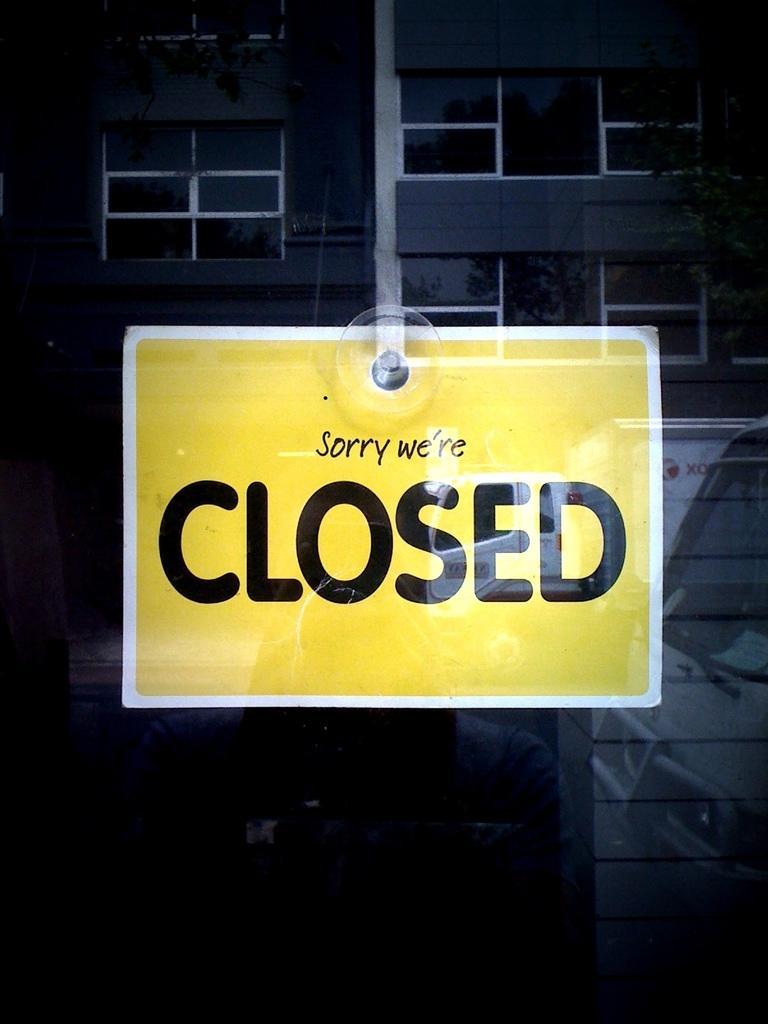Please provide a concise description of this image. In this image there is a display board, behind the board there is a building. 